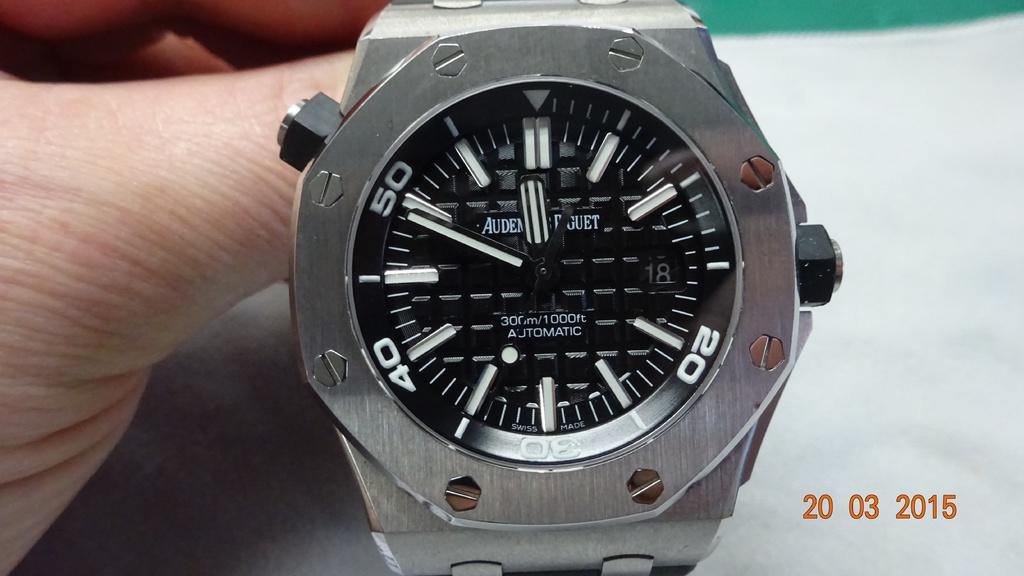<image>
Summarize the visual content of the image. A watch has "AUDEN" printed on the face. 